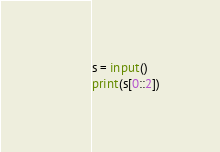<code> <loc_0><loc_0><loc_500><loc_500><_Python_>s = input()
print(s[0::2])
</code> 